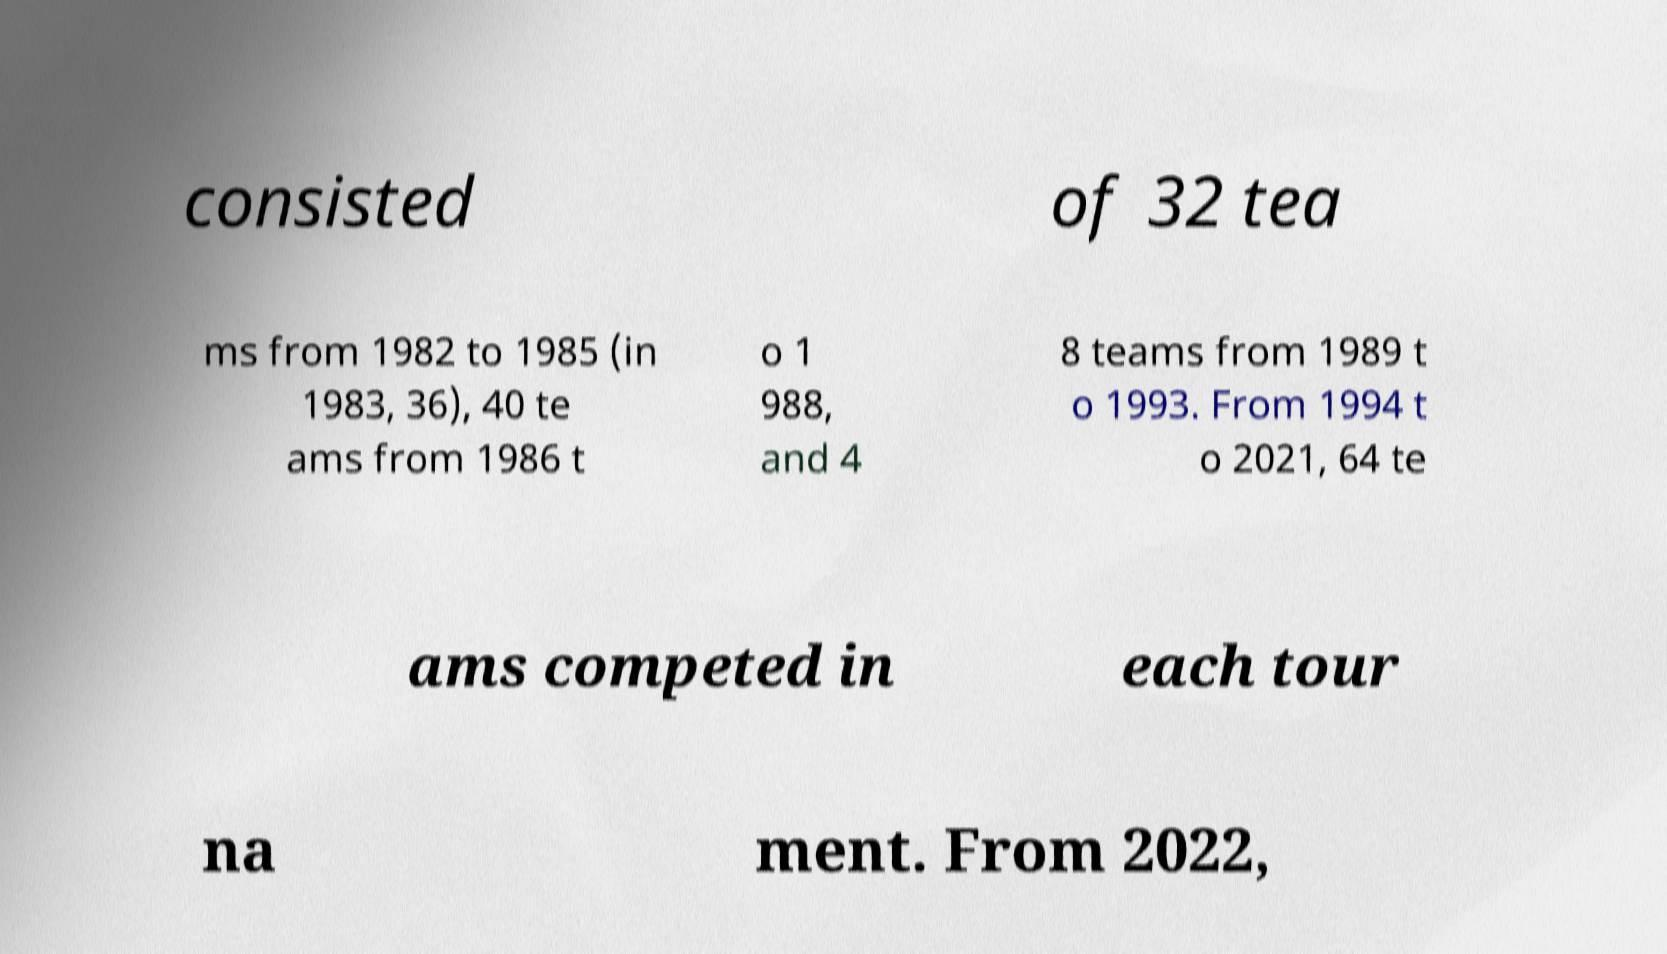Please read and relay the text visible in this image. What does it say? consisted of 32 tea ms from 1982 to 1985 (in 1983, 36), 40 te ams from 1986 t o 1 988, and 4 8 teams from 1989 t o 1993. From 1994 t o 2021, 64 te ams competed in each tour na ment. From 2022, 